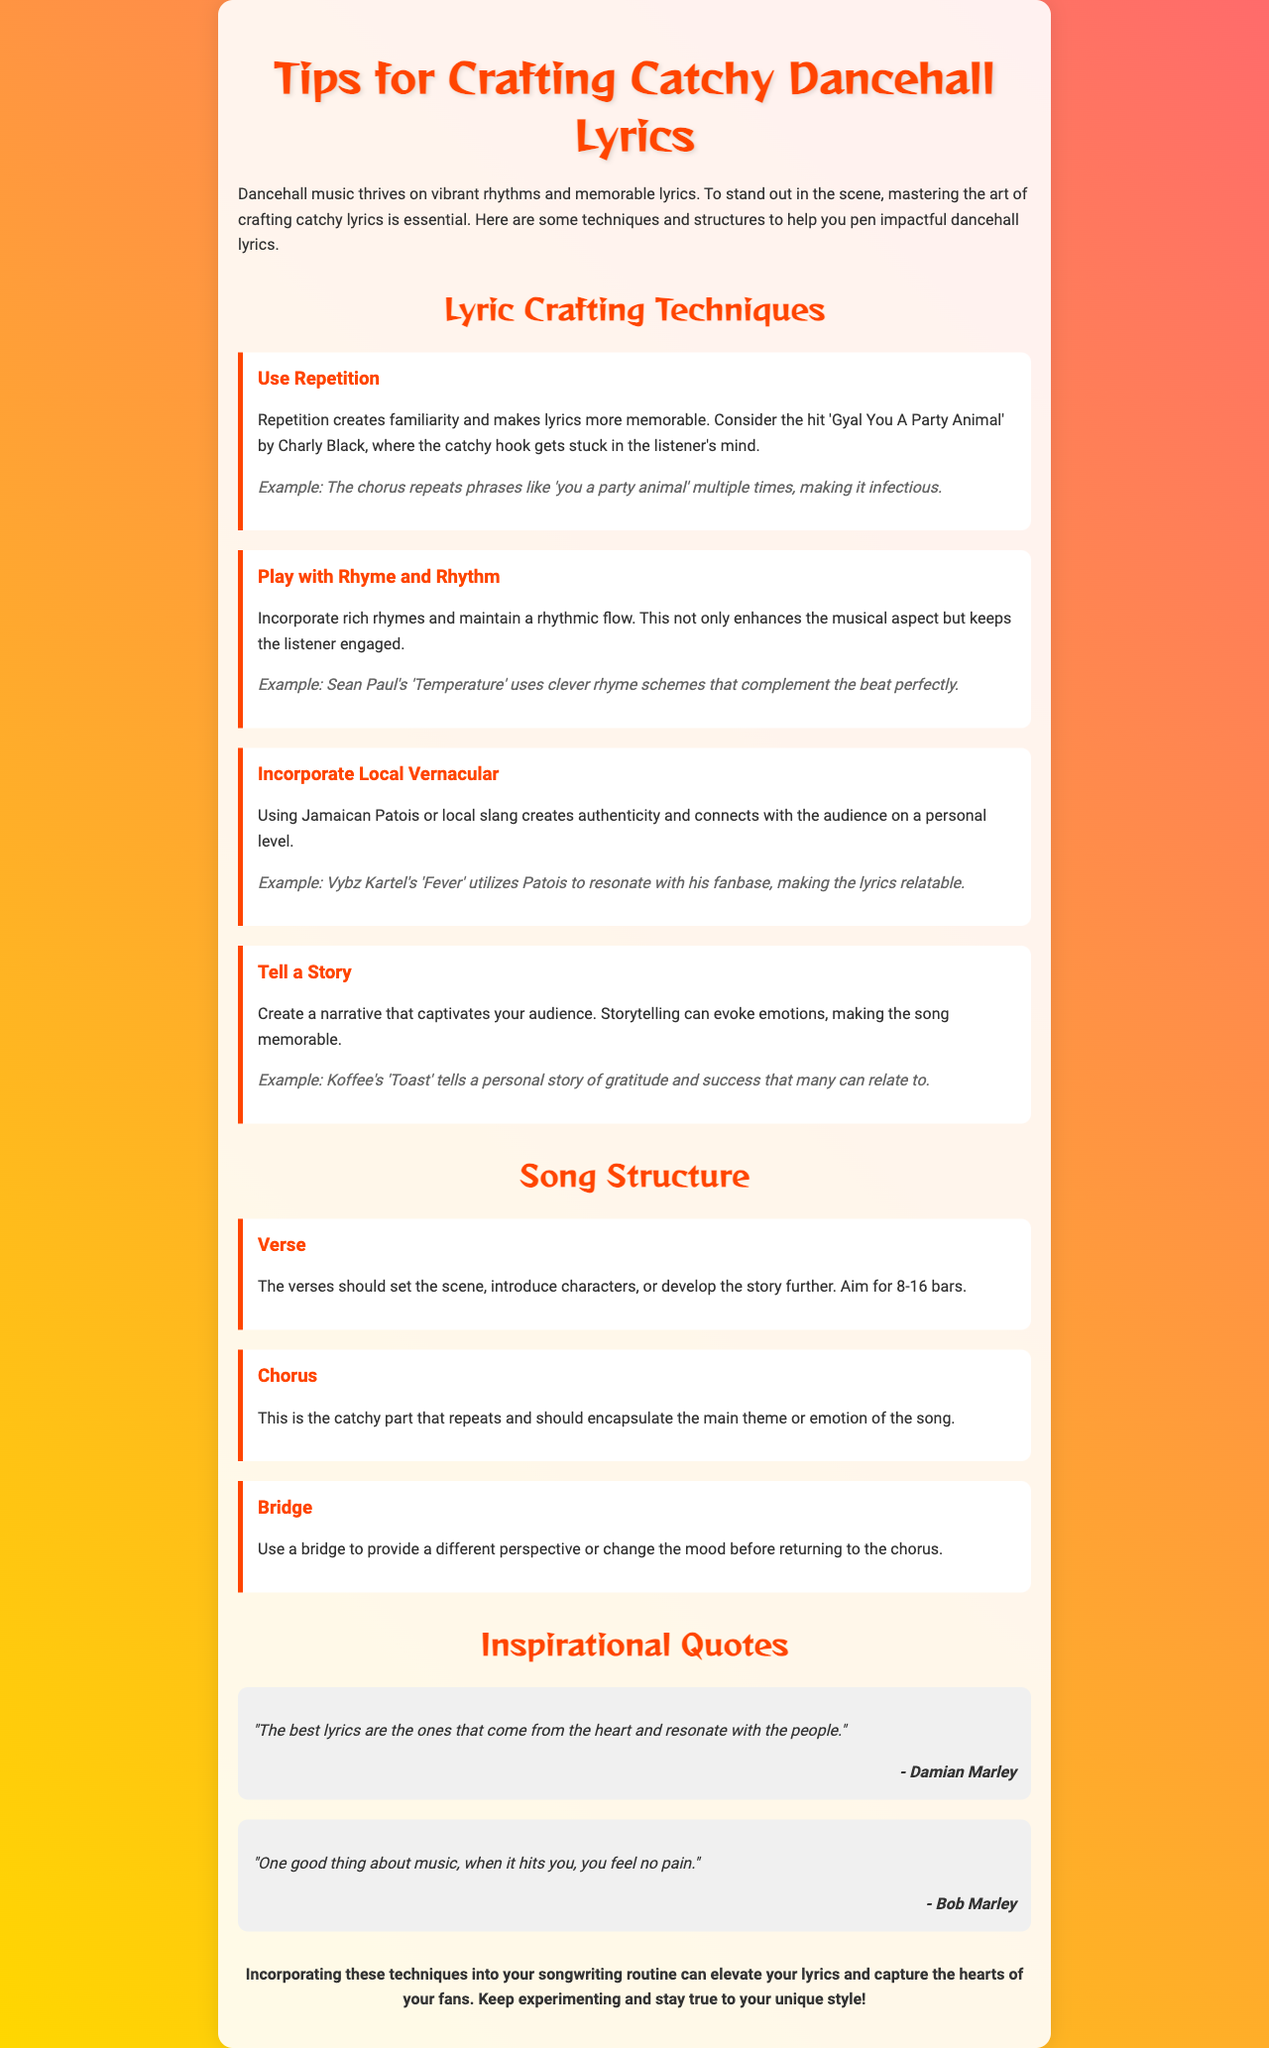What is the title of the newsletter? The title of the newsletter is presented prominently at the top of the document.
Answer: Tips for Crafting Catchy Dancehall Lyrics Who is the artist associated with the example "Gyal You A Party Animal"? The artist is mentioned as part of the lyric crafting techniques section, focusing on repetition.
Answer: Charly Black What technique is emphasized for making lyrics more memorable? The document outlines various techniques in crafting catchy lyrics, one of which stands out for increasing memorability.
Answer: Repetition Which song by Koffee is mentioned for storytelling? The song title is provided as an example in the storytelling technique section.
Answer: Toast What quote is attributed to Damian Marley? Quotes are provided to inspire and motivate lyric writers, one of which is attributed to a prominent artist.
Answer: "The best lyrics are the ones that come from the heart and resonate with the people." How many bars should verses aim for according to song structure? This information is provided in the song structure section, specifying the length of verses.
Answer: 8-16 bars What is the primary purpose of the chorus in a song? The document describes the role of various sections in a song, highlighting one specific aspect for the chorus.
Answer: To encapsulate the main theme or emotion of the song What color is used for the container's background? The background color of the container is mentioned in the styling section of the document.
Answer: rgba(255, 255, 255, 0.9) What is the main focus of the newsletter? The document outlines the overall aim around crafting lyrics, setting the thematic framework for the newsletter.
Answer: Crafting catchy lyrics 